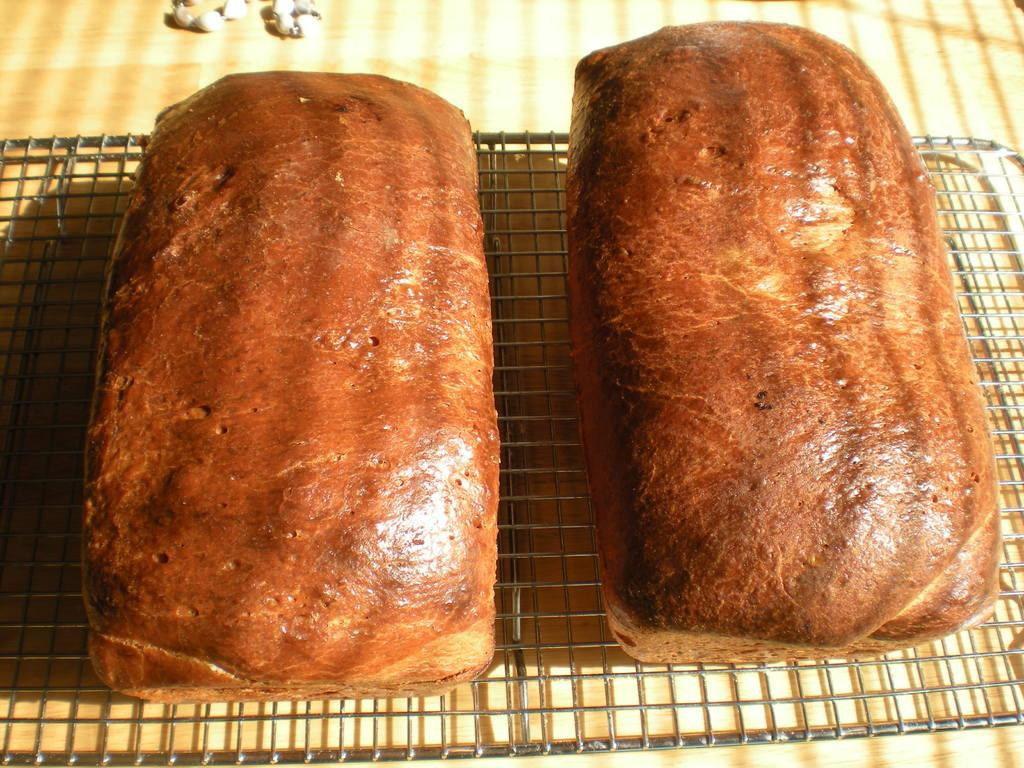What type of surface is visible in the image? There is a wooden platform in the image. What can be found on the wooden platform? Objects are present on the wooden platform. What activity is being performed in the image? There is food placed on a grill in the image. What type of mailbox can be seen on the wooden platform? There is no mailbox present on the wooden platform in the image. How does the grilling activity compare to other cooking methods? The provided facts do not allow for a comparison between grilling and other cooking methods. 